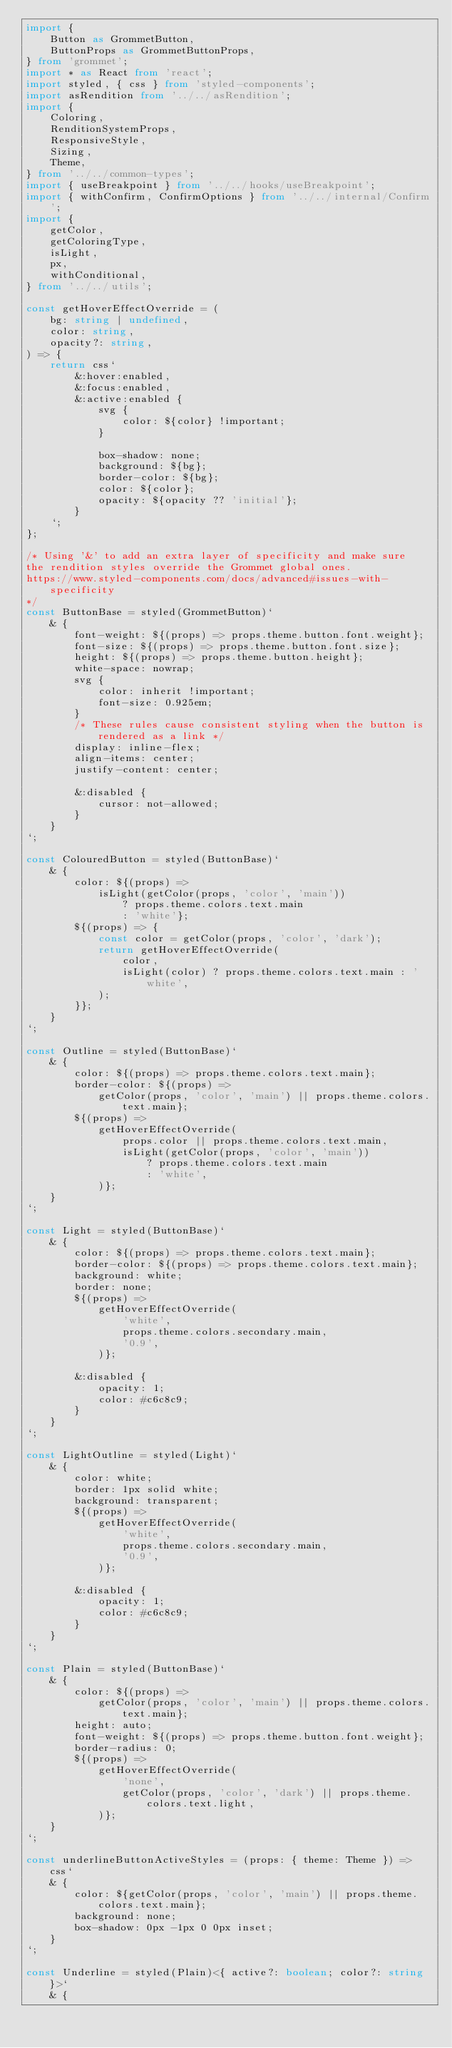<code> <loc_0><loc_0><loc_500><loc_500><_TypeScript_>import {
	Button as GrommetButton,
	ButtonProps as GrommetButtonProps,
} from 'grommet';
import * as React from 'react';
import styled, { css } from 'styled-components';
import asRendition from '../../asRendition';
import {
	Coloring,
	RenditionSystemProps,
	ResponsiveStyle,
	Sizing,
	Theme,
} from '../../common-types';
import { useBreakpoint } from '../../hooks/useBreakpoint';
import { withConfirm, ConfirmOptions } from '../../internal/Confirm';
import {
	getColor,
	getColoringType,
	isLight,
	px,
	withConditional,
} from '../../utils';

const getHoverEffectOverride = (
	bg: string | undefined,
	color: string,
	opacity?: string,
) => {
	return css`
		&:hover:enabled,
		&:focus:enabled,
		&:active:enabled {
			svg {
				color: ${color} !important;
			}

			box-shadow: none;
			background: ${bg};
			border-color: ${bg};
			color: ${color};
			opacity: ${opacity ?? 'initial'};
		}
	`;
};

/* Using '&' to add an extra layer of specificity and make sure
the rendition styles override the Grommet global ones.
https://www.styled-components.com/docs/advanced#issues-with-specificity
*/
const ButtonBase = styled(GrommetButton)`
	& {
		font-weight: ${(props) => props.theme.button.font.weight};
		font-size: ${(props) => props.theme.button.font.size};
		height: ${(props) => props.theme.button.height};
		white-space: nowrap;
		svg {
			color: inherit !important;
			font-size: 0.925em;
		}
		/* These rules cause consistent styling when the button is rendered as a link */
		display: inline-flex;
		align-items: center;
		justify-content: center;

		&:disabled {
			cursor: not-allowed;
		}
	}
`;

const ColouredButton = styled(ButtonBase)`
	& {
		color: ${(props) =>
			isLight(getColor(props, 'color', 'main'))
				? props.theme.colors.text.main
				: 'white'};
		${(props) => {
			const color = getColor(props, 'color', 'dark');
			return getHoverEffectOverride(
				color,
				isLight(color) ? props.theme.colors.text.main : 'white',
			);
		}};
	}
`;

const Outline = styled(ButtonBase)`
	& {
		color: ${(props) => props.theme.colors.text.main};
		border-color: ${(props) =>
			getColor(props, 'color', 'main') || props.theme.colors.text.main};
		${(props) =>
			getHoverEffectOverride(
				props.color || props.theme.colors.text.main,
				isLight(getColor(props, 'color', 'main'))
					? props.theme.colors.text.main
					: 'white',
			)};
	}
`;

const Light = styled(ButtonBase)`
	& {
		color: ${(props) => props.theme.colors.text.main};
		border-color: ${(props) => props.theme.colors.text.main};
		background: white;
		border: none;
		${(props) =>
			getHoverEffectOverride(
				'white',
				props.theme.colors.secondary.main,
				'0.9',
			)};

		&:disabled {
			opacity: 1;
			color: #c6c8c9;
		}
	}
`;

const LightOutline = styled(Light)`
	& {
		color: white;
		border: 1px solid white;
		background: transparent;
		${(props) =>
			getHoverEffectOverride(
				'white',
				props.theme.colors.secondary.main,
				'0.9',
			)};

		&:disabled {
			opacity: 1;
			color: #c6c8c9;
		}
	}
`;

const Plain = styled(ButtonBase)`
	& {
		color: ${(props) =>
			getColor(props, 'color', 'main') || props.theme.colors.text.main};
		height: auto;
		font-weight: ${(props) => props.theme.button.font.weight};
		border-radius: 0;
		${(props) =>
			getHoverEffectOverride(
				'none',
				getColor(props, 'color', 'dark') || props.theme.colors.text.light,
			)};
	}
`;

const underlineButtonActiveStyles = (props: { theme: Theme }) => css`
	& {
		color: ${getColor(props, 'color', 'main') || props.theme.colors.text.main};
		background: none;
		box-shadow: 0px -1px 0 0px inset;
	}
`;

const Underline = styled(Plain)<{ active?: boolean; color?: string }>`
	& {</code> 